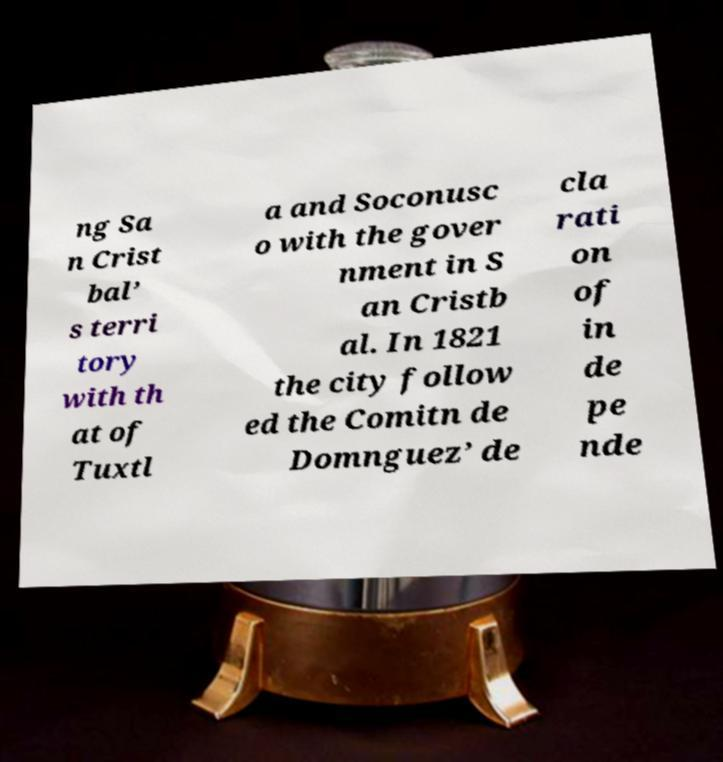There's text embedded in this image that I need extracted. Can you transcribe it verbatim? ng Sa n Crist bal’ s terri tory with th at of Tuxtl a and Soconusc o with the gover nment in S an Cristb al. In 1821 the city follow ed the Comitn de Domnguez’ de cla rati on of in de pe nde 